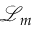Convert formula to latex. <formula><loc_0><loc_0><loc_500><loc_500>{ \mathcal { L } } _ { m }</formula> 